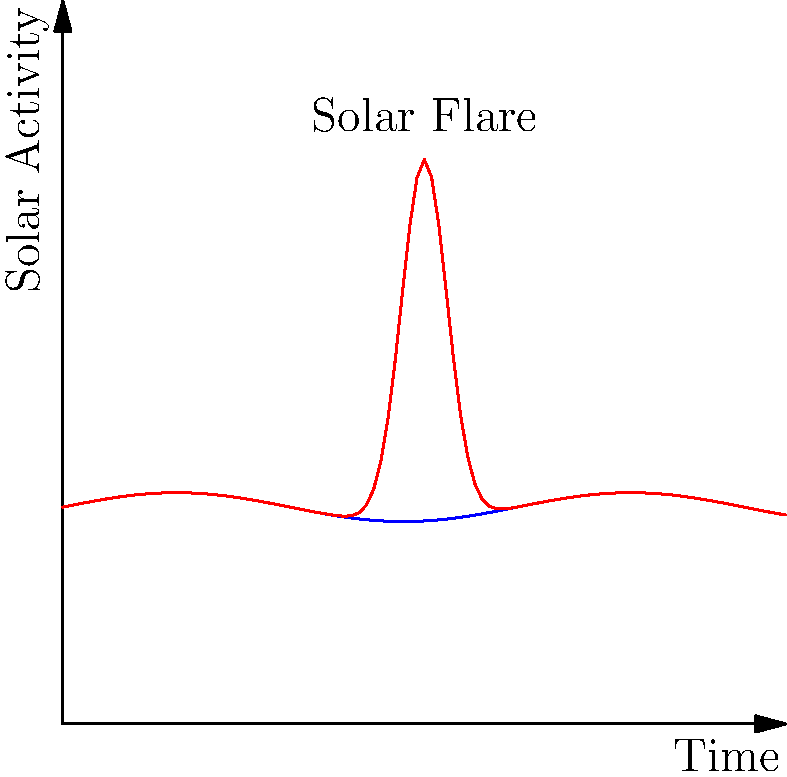In the context of space weather monitoring for astronautical missions, how would an anomaly detection algorithm identify the solar flare event shown in the graph, and what key features would it likely use to distinguish this event from normal solar activity? To identify the solar flare event using an anomaly detection algorithm, we would follow these steps:

1. Establish a baseline: The algorithm would first learn the pattern of normal solar activity, represented by the blue line in the graph. This baseline shows a relatively stable pattern with small periodic fluctuations.

2. Define threshold: Set a threshold for what constitutes an anomaly. This could be based on statistical measures like standard deviations from the mean activity level.

3. Feature extraction: Key features the algorithm would likely use include:
   a) Amplitude: The sudden increase in solar activity, reaching a peak much higher than the normal range.
   b) Rate of change: The rapid rise and fall of activity levels.
   c) Duration: The relatively short time span of the high-intensity event.
   d) Shape: The characteristic spike shape of the flare event.

4. Pattern recognition: The algorithm would scan the incoming data (red line) for patterns that deviate significantly from the baseline.

5. Anomaly detection: When the algorithm detects values exceeding the threshold and matching the characteristic features of a solar flare, it would flag this as an anomaly.

6. Classification: Based on the specific characteristics (amplitude, duration, etc.), the algorithm could potentially classify the type and intensity of the solar flare.

7. Alert system: Once detected, the system would generate an alert for space weather forecasters and mission control to take appropriate action.

The effectiveness of the algorithm relies on its ability to accurately distinguish between normal variations in solar activity and genuine anomalies like solar flares, minimizing false positives while ensuring no significant events are missed.
Answer: Sudden spike in amplitude, rapid rate of change, short duration, and characteristic shape deviating from baseline activity. 